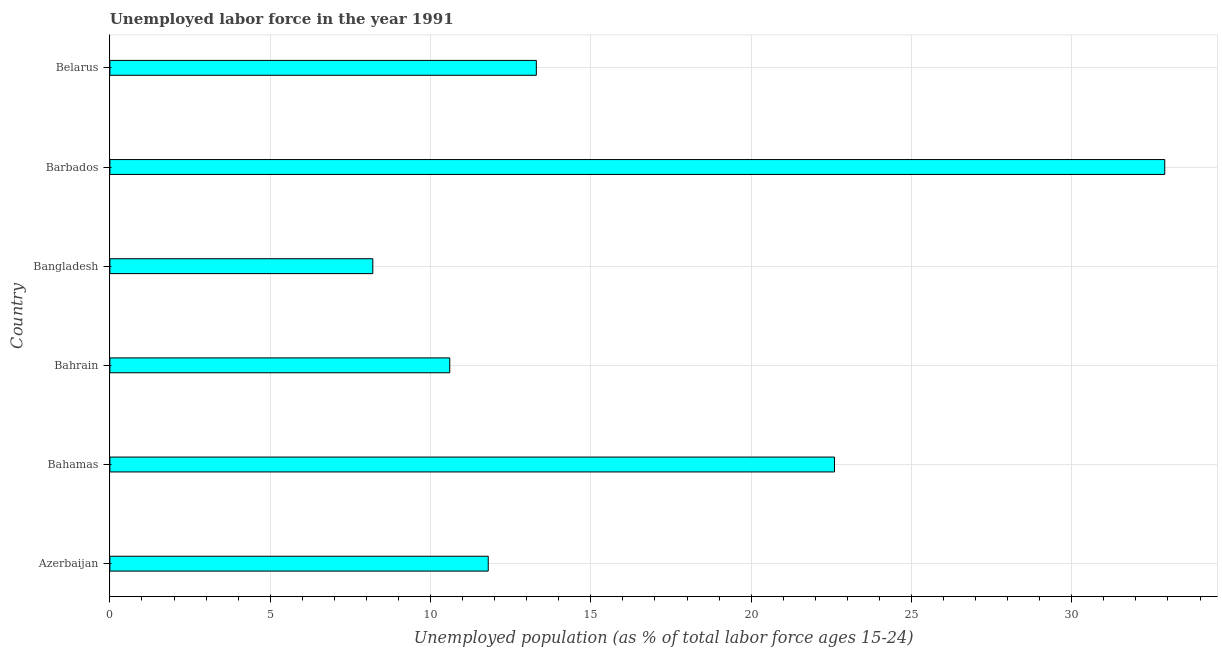Does the graph contain any zero values?
Your answer should be compact. No. What is the title of the graph?
Give a very brief answer. Unemployed labor force in the year 1991. What is the label or title of the X-axis?
Your answer should be compact. Unemployed population (as % of total labor force ages 15-24). What is the label or title of the Y-axis?
Provide a short and direct response. Country. What is the total unemployed youth population in Bahamas?
Your answer should be very brief. 22.6. Across all countries, what is the maximum total unemployed youth population?
Your answer should be compact. 32.9. Across all countries, what is the minimum total unemployed youth population?
Your answer should be very brief. 8.2. In which country was the total unemployed youth population maximum?
Make the answer very short. Barbados. What is the sum of the total unemployed youth population?
Ensure brevity in your answer.  99.4. What is the difference between the total unemployed youth population in Azerbaijan and Bahamas?
Give a very brief answer. -10.8. What is the average total unemployed youth population per country?
Your response must be concise. 16.57. What is the median total unemployed youth population?
Your response must be concise. 12.55. What is the ratio of the total unemployed youth population in Azerbaijan to that in Belarus?
Your answer should be very brief. 0.89. Is the total unemployed youth population in Barbados less than that in Belarus?
Give a very brief answer. No. Is the difference between the total unemployed youth population in Bangladesh and Barbados greater than the difference between any two countries?
Offer a very short reply. Yes. What is the difference between the highest and the second highest total unemployed youth population?
Ensure brevity in your answer.  10.3. Is the sum of the total unemployed youth population in Azerbaijan and Bahamas greater than the maximum total unemployed youth population across all countries?
Your response must be concise. Yes. What is the difference between the highest and the lowest total unemployed youth population?
Provide a short and direct response. 24.7. How many bars are there?
Your response must be concise. 6. What is the difference between two consecutive major ticks on the X-axis?
Provide a succinct answer. 5. Are the values on the major ticks of X-axis written in scientific E-notation?
Your response must be concise. No. What is the Unemployed population (as % of total labor force ages 15-24) in Azerbaijan?
Make the answer very short. 11.8. What is the Unemployed population (as % of total labor force ages 15-24) in Bahamas?
Ensure brevity in your answer.  22.6. What is the Unemployed population (as % of total labor force ages 15-24) of Bahrain?
Your response must be concise. 10.6. What is the Unemployed population (as % of total labor force ages 15-24) of Bangladesh?
Make the answer very short. 8.2. What is the Unemployed population (as % of total labor force ages 15-24) in Barbados?
Offer a terse response. 32.9. What is the Unemployed population (as % of total labor force ages 15-24) in Belarus?
Your response must be concise. 13.3. What is the difference between the Unemployed population (as % of total labor force ages 15-24) in Azerbaijan and Bangladesh?
Make the answer very short. 3.6. What is the difference between the Unemployed population (as % of total labor force ages 15-24) in Azerbaijan and Barbados?
Offer a very short reply. -21.1. What is the difference between the Unemployed population (as % of total labor force ages 15-24) in Bahamas and Bangladesh?
Keep it short and to the point. 14.4. What is the difference between the Unemployed population (as % of total labor force ages 15-24) in Bahamas and Barbados?
Offer a very short reply. -10.3. What is the difference between the Unemployed population (as % of total labor force ages 15-24) in Bahamas and Belarus?
Keep it short and to the point. 9.3. What is the difference between the Unemployed population (as % of total labor force ages 15-24) in Bahrain and Bangladesh?
Your answer should be compact. 2.4. What is the difference between the Unemployed population (as % of total labor force ages 15-24) in Bahrain and Barbados?
Provide a short and direct response. -22.3. What is the difference between the Unemployed population (as % of total labor force ages 15-24) in Bangladesh and Barbados?
Your answer should be very brief. -24.7. What is the difference between the Unemployed population (as % of total labor force ages 15-24) in Barbados and Belarus?
Your response must be concise. 19.6. What is the ratio of the Unemployed population (as % of total labor force ages 15-24) in Azerbaijan to that in Bahamas?
Ensure brevity in your answer.  0.52. What is the ratio of the Unemployed population (as % of total labor force ages 15-24) in Azerbaijan to that in Bahrain?
Offer a terse response. 1.11. What is the ratio of the Unemployed population (as % of total labor force ages 15-24) in Azerbaijan to that in Bangladesh?
Offer a terse response. 1.44. What is the ratio of the Unemployed population (as % of total labor force ages 15-24) in Azerbaijan to that in Barbados?
Offer a terse response. 0.36. What is the ratio of the Unemployed population (as % of total labor force ages 15-24) in Azerbaijan to that in Belarus?
Your response must be concise. 0.89. What is the ratio of the Unemployed population (as % of total labor force ages 15-24) in Bahamas to that in Bahrain?
Your answer should be compact. 2.13. What is the ratio of the Unemployed population (as % of total labor force ages 15-24) in Bahamas to that in Bangladesh?
Make the answer very short. 2.76. What is the ratio of the Unemployed population (as % of total labor force ages 15-24) in Bahamas to that in Barbados?
Provide a short and direct response. 0.69. What is the ratio of the Unemployed population (as % of total labor force ages 15-24) in Bahamas to that in Belarus?
Give a very brief answer. 1.7. What is the ratio of the Unemployed population (as % of total labor force ages 15-24) in Bahrain to that in Bangladesh?
Offer a very short reply. 1.29. What is the ratio of the Unemployed population (as % of total labor force ages 15-24) in Bahrain to that in Barbados?
Your response must be concise. 0.32. What is the ratio of the Unemployed population (as % of total labor force ages 15-24) in Bahrain to that in Belarus?
Your response must be concise. 0.8. What is the ratio of the Unemployed population (as % of total labor force ages 15-24) in Bangladesh to that in Barbados?
Provide a short and direct response. 0.25. What is the ratio of the Unemployed population (as % of total labor force ages 15-24) in Bangladesh to that in Belarus?
Your response must be concise. 0.62. What is the ratio of the Unemployed population (as % of total labor force ages 15-24) in Barbados to that in Belarus?
Offer a terse response. 2.47. 